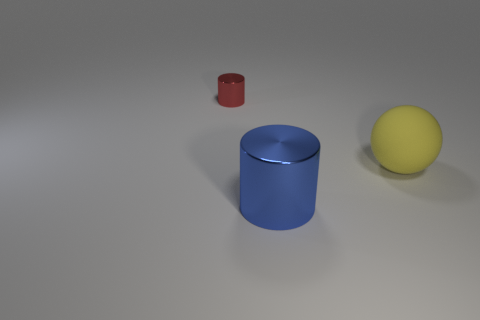Add 3 large blocks. How many objects exist? 6 Add 1 small red cylinders. How many small red cylinders exist? 2 Subtract 1 blue cylinders. How many objects are left? 2 Subtract all cylinders. How many objects are left? 1 Subtract all tiny gray rubber cylinders. Subtract all large blue cylinders. How many objects are left? 2 Add 2 tiny metallic things. How many tiny metallic things are left? 3 